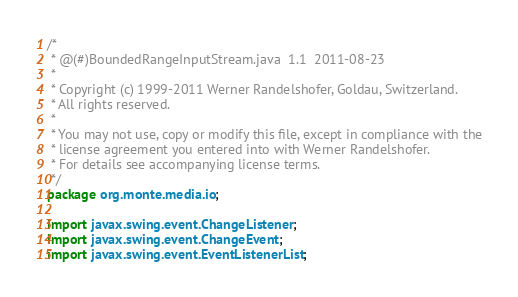<code> <loc_0><loc_0><loc_500><loc_500><_Java_>/*
 * @(#)BoundedRangeInputStream.java  1.1  2011-08-23
 *
 * Copyright (c) 1999-2011 Werner Randelshofer, Goldau, Switzerland.
 * All rights reserved.
 *
 * You may not use, copy or modify this file, except in compliance with the
 * license agreement you entered into with Werner Randelshofer.
 * For details see accompanying license terms.
 */
package org.monte.media.io;

import javax.swing.event.ChangeListener;
import javax.swing.event.ChangeEvent;
import javax.swing.event.EventListenerList;</code> 